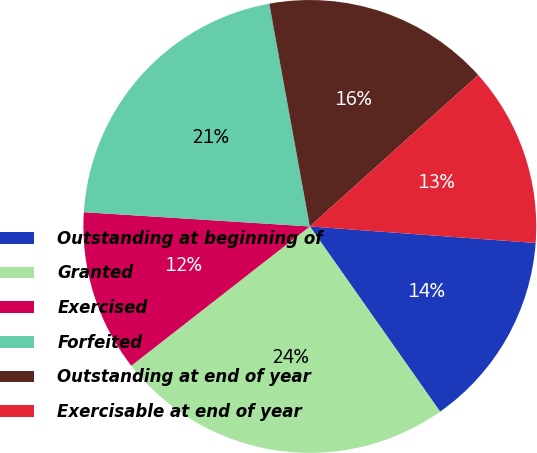Convert chart to OTSL. <chart><loc_0><loc_0><loc_500><loc_500><pie_chart><fcel>Outstanding at beginning of<fcel>Granted<fcel>Exercised<fcel>Forfeited<fcel>Outstanding at end of year<fcel>Exercisable at end of year<nl><fcel>14.08%<fcel>24.21%<fcel>11.55%<fcel>21.13%<fcel>16.21%<fcel>12.82%<nl></chart> 